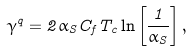<formula> <loc_0><loc_0><loc_500><loc_500>\gamma ^ { q } = 2 \alpha _ { S } C _ { f } T _ { c } \ln \left [ \frac { 1 } { \alpha _ { S } } \right ] ,</formula> 